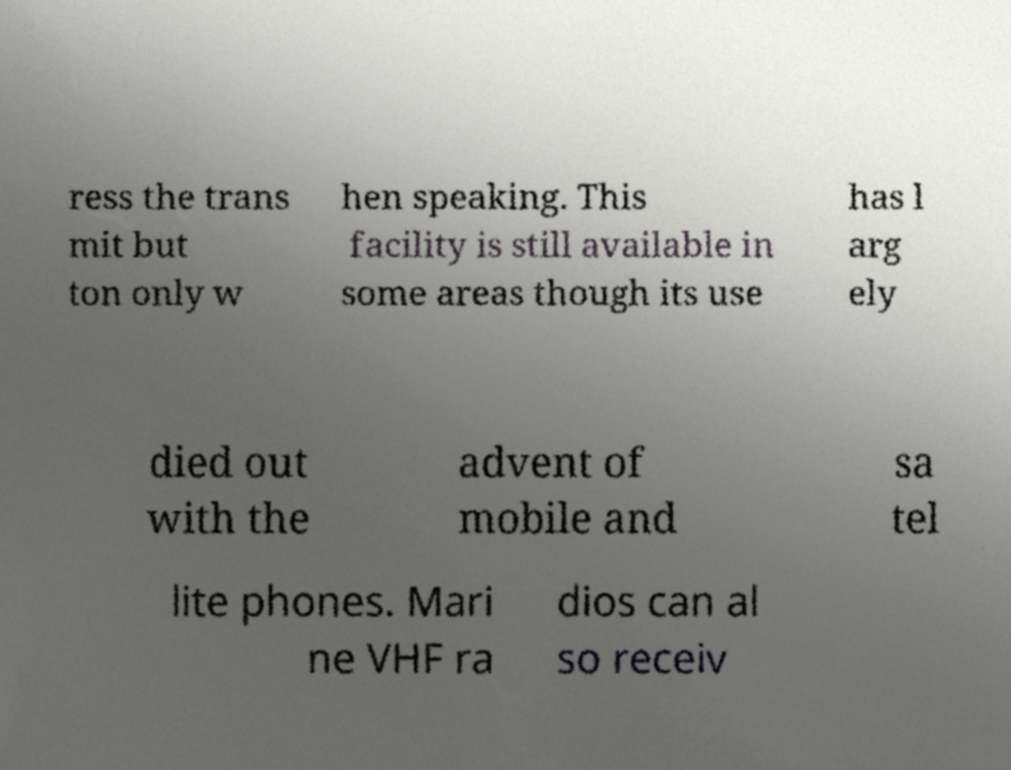Please read and relay the text visible in this image. What does it say? ress the trans mit but ton only w hen speaking. This facility is still available in some areas though its use has l arg ely died out with the advent of mobile and sa tel lite phones. Mari ne VHF ra dios can al so receiv 